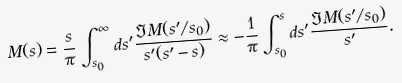<formula> <loc_0><loc_0><loc_500><loc_500>M ( s ) = \frac { s } { \pi } \int _ { s _ { 0 } } ^ { \infty } d s ^ { \prime } \frac { \Im M ( s ^ { \prime } / s _ { 0 } ) } { s ^ { \prime } ( s ^ { \prime } - s ) } \approx - \frac { 1 } { \pi } \int _ { s _ { 0 } } ^ { s } d s ^ { \prime } \frac { \Im M ( s ^ { \prime } / s _ { 0 } ) } { s ^ { \prime } } .</formula> 